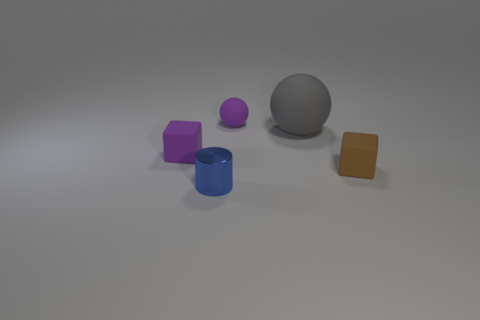Subtract 1 blocks. How many blocks are left? 1 Add 3 big cyan rubber objects. How many objects exist? 8 Subtract all yellow balls. How many brown cubes are left? 1 Subtract all red spheres. Subtract all blue cylinders. How many spheres are left? 2 Subtract all yellow metal cubes. Subtract all brown objects. How many objects are left? 4 Add 4 tiny purple matte blocks. How many tiny purple matte blocks are left? 5 Add 3 tiny purple rubber spheres. How many tiny purple rubber spheres exist? 4 Subtract 0 blue cubes. How many objects are left? 5 Subtract all spheres. How many objects are left? 3 